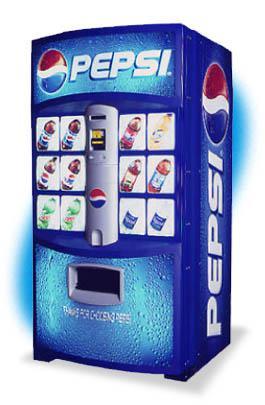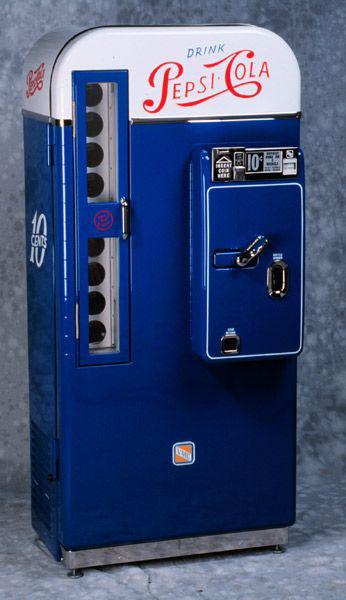The first image is the image on the left, the second image is the image on the right. Considering the images on both sides, is "Each image shows predominantly one vending machine, and all vending machines shown are blue." valid? Answer yes or no. Yes. The first image is the image on the left, the second image is the image on the right. Given the left and right images, does the statement "In one of the images, a pepsi machine stands alone." hold true? Answer yes or no. Yes. 